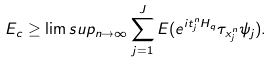Convert formula to latex. <formula><loc_0><loc_0><loc_500><loc_500>E _ { c } \geq \lim s u p _ { n \rightarrow \infty } \sum _ { j = 1 } ^ { J } E ( e ^ { i t _ { j } ^ { n } H _ { q } } \tau _ { x _ { j } ^ { n } } \psi _ { j } ) .</formula> 